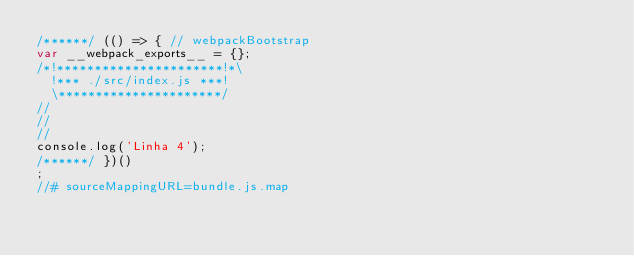Convert code to text. <code><loc_0><loc_0><loc_500><loc_500><_JavaScript_>/******/ (() => { // webpackBootstrap
var __webpack_exports__ = {};
/*!**********************!*\
  !*** ./src/index.js ***!
  \**********************/
//
//
//
console.log('Linha 4');
/******/ })()
;
//# sourceMappingURL=bundle.js.map</code> 